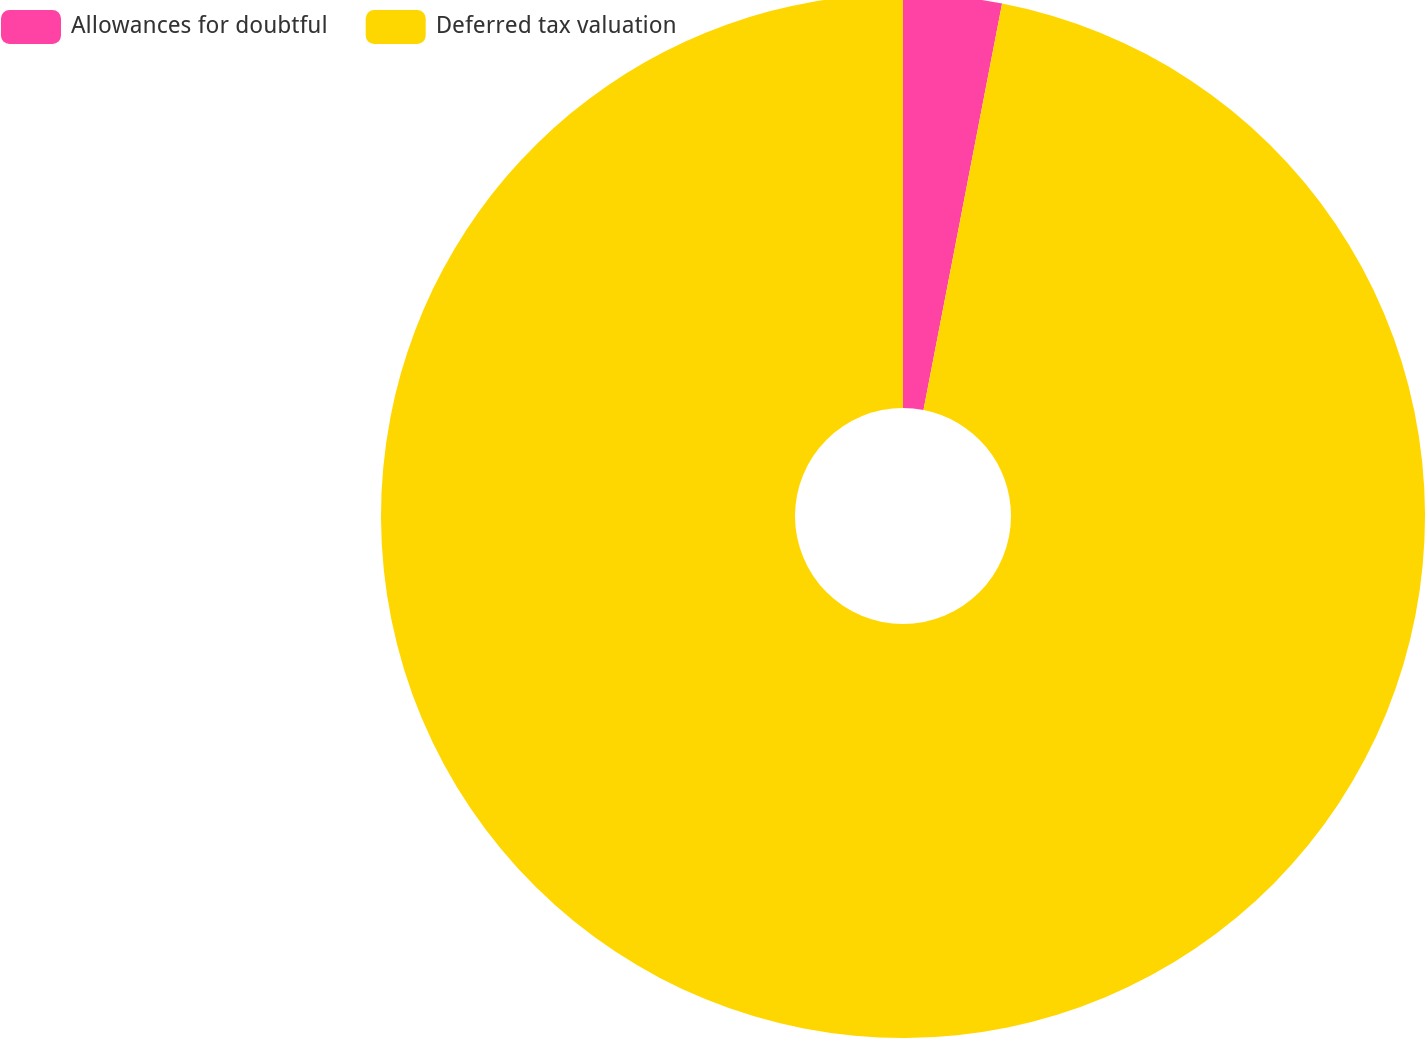<chart> <loc_0><loc_0><loc_500><loc_500><pie_chart><fcel>Allowances for doubtful<fcel>Deferred tax valuation<nl><fcel>3.04%<fcel>96.96%<nl></chart> 